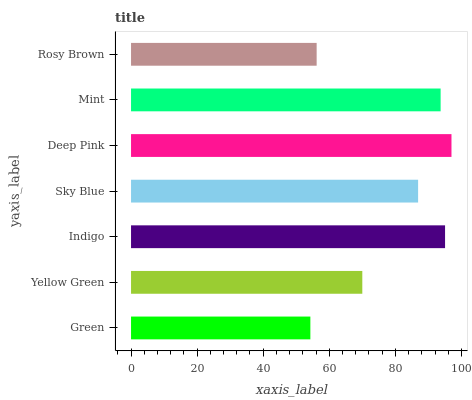Is Green the minimum?
Answer yes or no. Yes. Is Deep Pink the maximum?
Answer yes or no. Yes. Is Yellow Green the minimum?
Answer yes or no. No. Is Yellow Green the maximum?
Answer yes or no. No. Is Yellow Green greater than Green?
Answer yes or no. Yes. Is Green less than Yellow Green?
Answer yes or no. Yes. Is Green greater than Yellow Green?
Answer yes or no. No. Is Yellow Green less than Green?
Answer yes or no. No. Is Sky Blue the high median?
Answer yes or no. Yes. Is Sky Blue the low median?
Answer yes or no. Yes. Is Rosy Brown the high median?
Answer yes or no. No. Is Mint the low median?
Answer yes or no. No. 